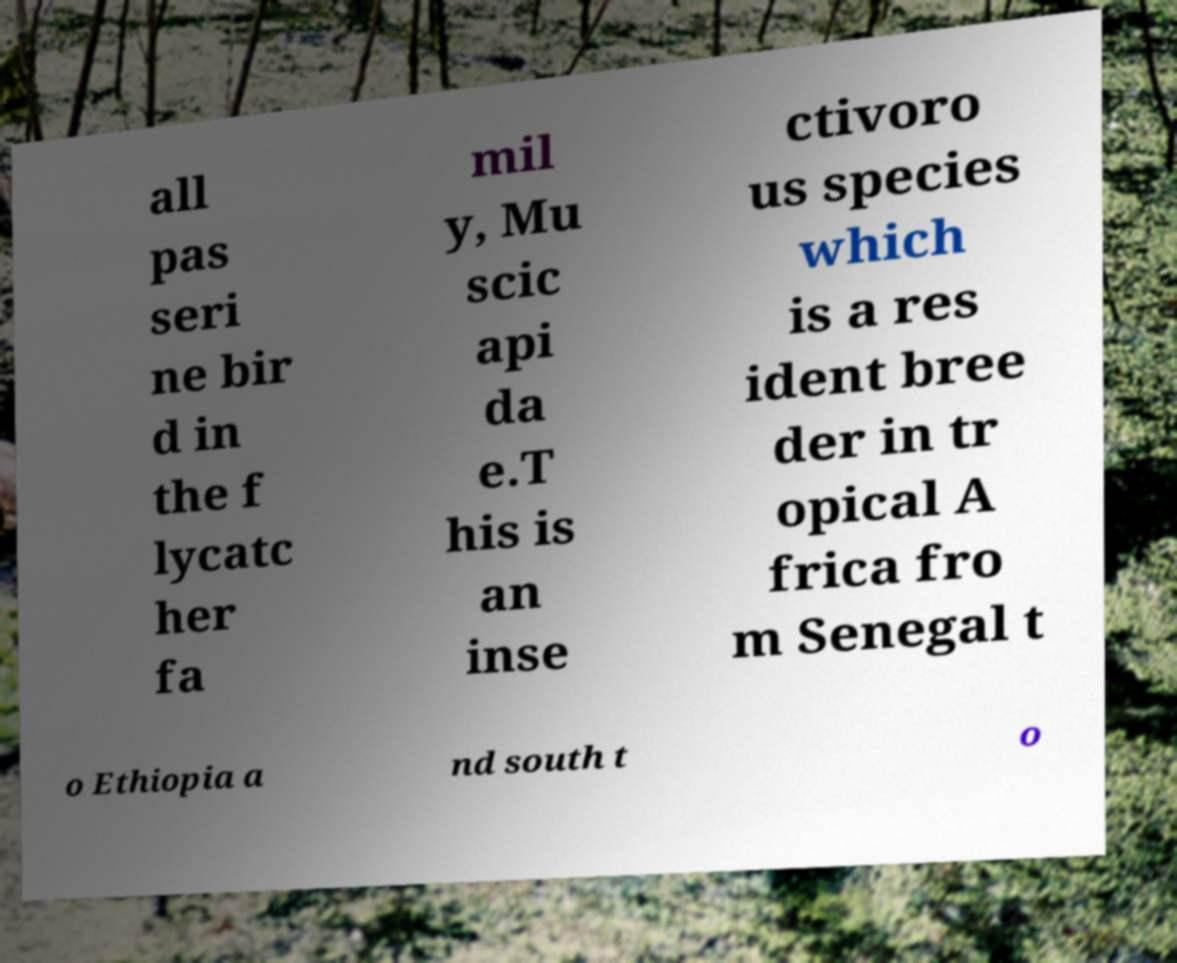Please read and relay the text visible in this image. What does it say? all pas seri ne bir d in the f lycatc her fa mil y, Mu scic api da e.T his is an inse ctivoro us species which is a res ident bree der in tr opical A frica fro m Senegal t o Ethiopia a nd south t o 